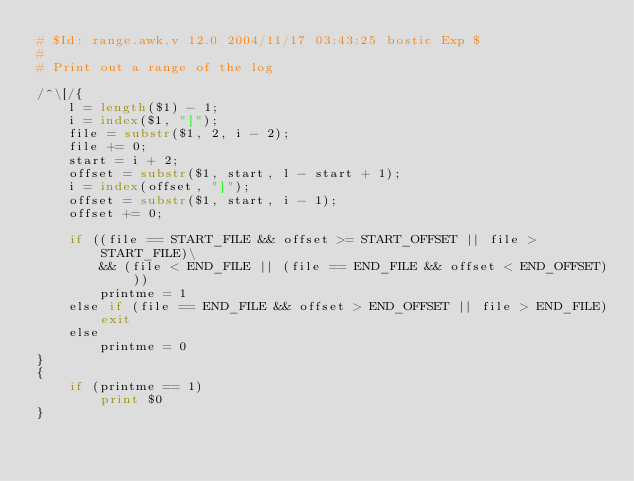<code> <loc_0><loc_0><loc_500><loc_500><_Awk_># $Id: range.awk,v 12.0 2004/11/17 03:43:25 bostic Exp $
#
# Print out a range of the log

/^\[/{
	l = length($1) - 1;
	i = index($1, "]");
	file = substr($1, 2, i - 2);
	file += 0;
	start = i + 2;
	offset = substr($1, start, l - start + 1);
	i = index(offset, "]");
	offset = substr($1, start, i - 1);
	offset += 0;

	if ((file == START_FILE && offset >= START_OFFSET || file > START_FILE)\
	    && (file < END_FILE || (file == END_FILE && offset < END_OFFSET)))
		printme = 1
	else if (file == END_FILE && offset > END_OFFSET || file > END_FILE)
		exit
	else
		printme = 0
}
{
	if (printme == 1)
		print $0
}
</code> 